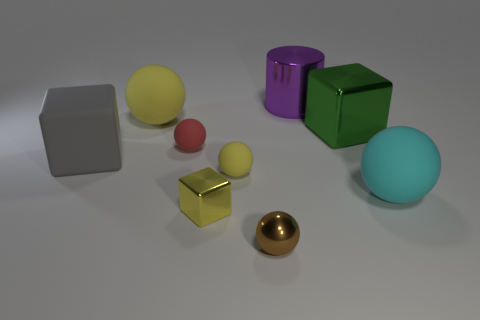Subtract 1 spheres. How many spheres are left? 4 Subtract all cyan balls. How many balls are left? 4 Subtract all tiny red matte spheres. How many spheres are left? 4 Subtract all purple balls. Subtract all yellow cylinders. How many balls are left? 5 Subtract all cylinders. How many objects are left? 8 Subtract all green metal blocks. Subtract all big metallic things. How many objects are left? 6 Add 2 large blocks. How many large blocks are left? 4 Add 2 yellow matte objects. How many yellow matte objects exist? 4 Subtract 0 green spheres. How many objects are left? 9 